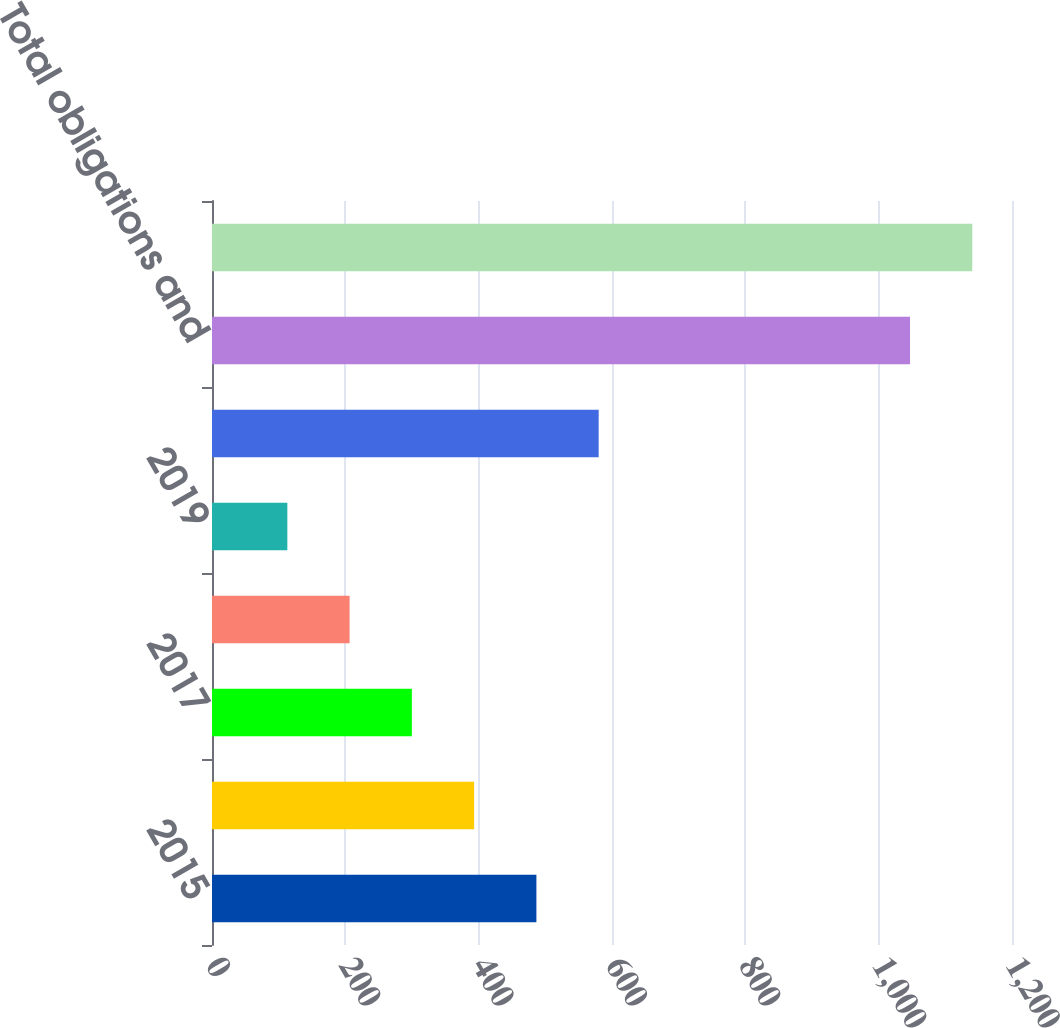<chart> <loc_0><loc_0><loc_500><loc_500><bar_chart><fcel>2015<fcel>2016<fcel>2017<fcel>2018<fcel>2019<fcel>Thereafter<fcel>Total obligations and<fcel>Total debt and lease<nl><fcel>486.6<fcel>393.2<fcel>299.8<fcel>206.4<fcel>113<fcel>580<fcel>1047<fcel>1140.4<nl></chart> 